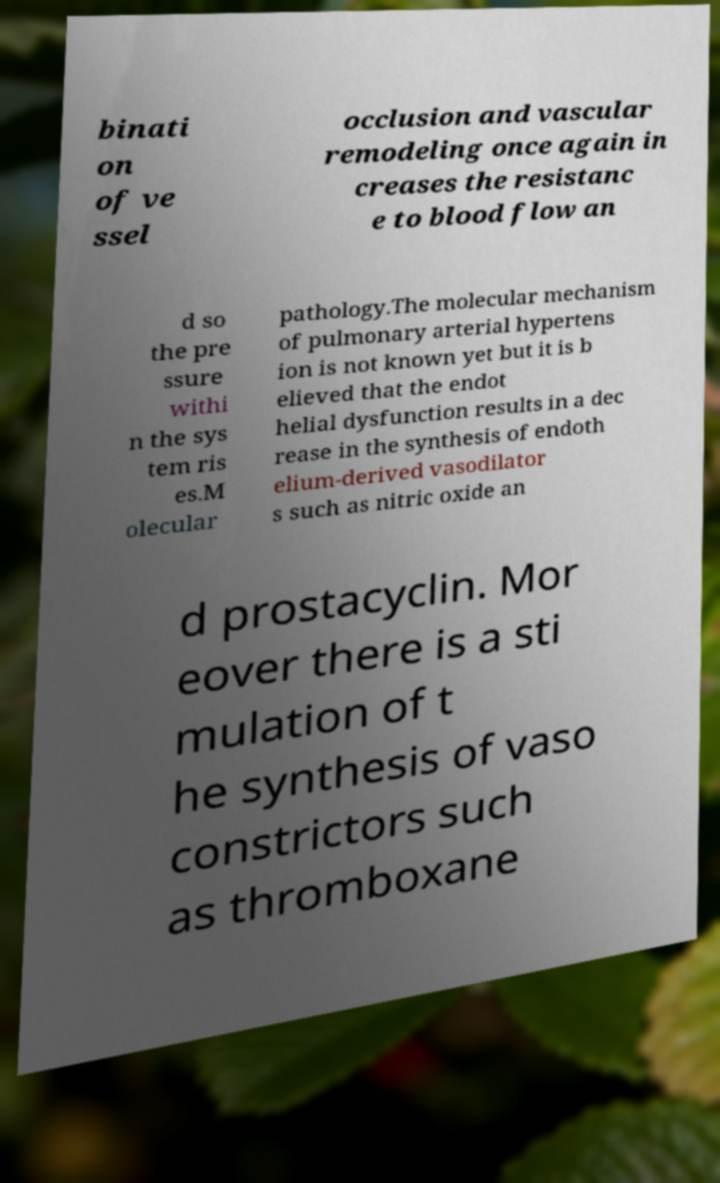I need the written content from this picture converted into text. Can you do that? binati on of ve ssel occlusion and vascular remodeling once again in creases the resistanc e to blood flow an d so the pre ssure withi n the sys tem ris es.M olecular pathology.The molecular mechanism of pulmonary arterial hypertens ion is not known yet but it is b elieved that the endot helial dysfunction results in a dec rease in the synthesis of endoth elium-derived vasodilator s such as nitric oxide an d prostacyclin. Mor eover there is a sti mulation of t he synthesis of vaso constrictors such as thromboxane 